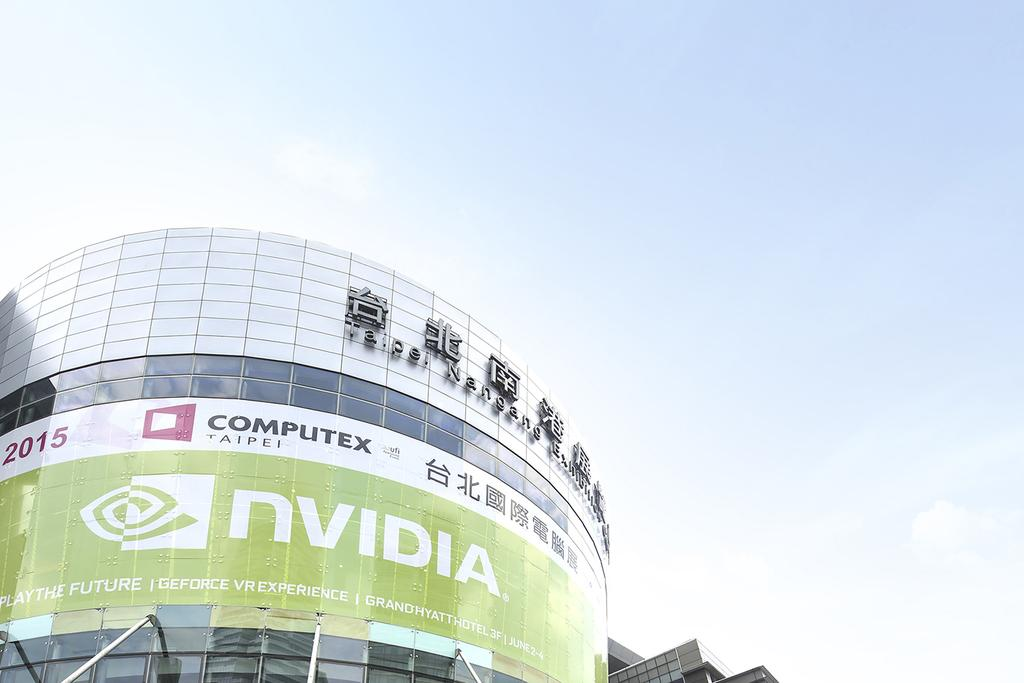What structure is located on the left side of the image? There is a building on the left side of the image. What is attached to the building in the image? The building has a banner on it. What is visible at the top of the image? The sky is visible in the image. What can be seen in the sky in the image? There are clouds in the sky. What type of sign is the authority using to communicate with the public in the image? There is no sign or authority present in the image; it only features a building with a banner and clouds in the sky. 